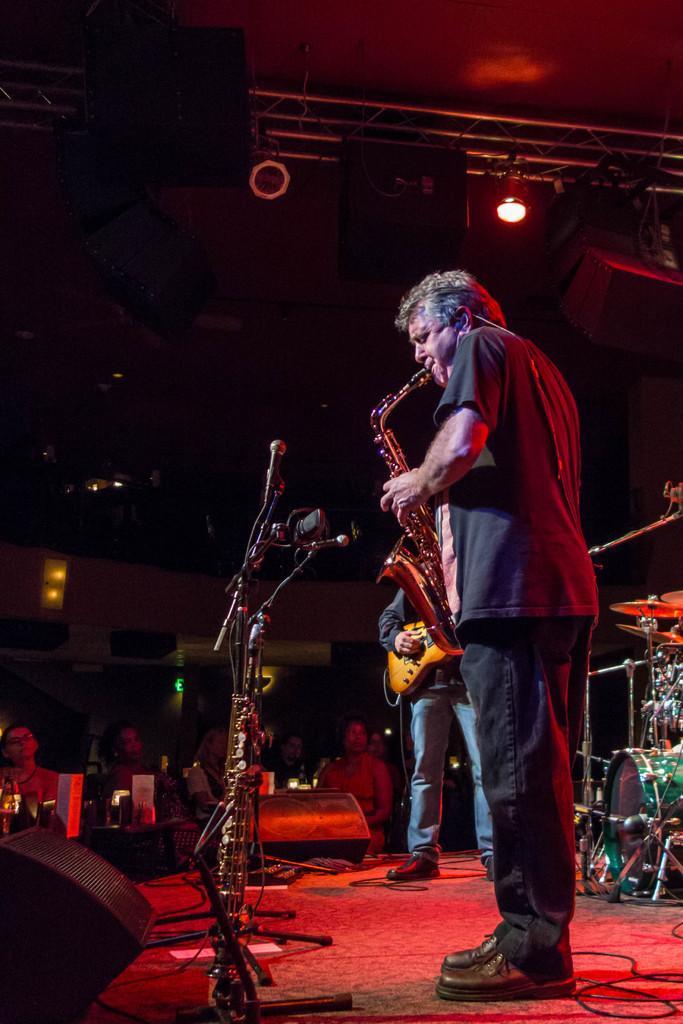In one or two sentences, can you explain what this image depicts? In this picture we can see a person playing a saxophone , and a person standing beside him is playing a guitar. These people are standing on the dais. 